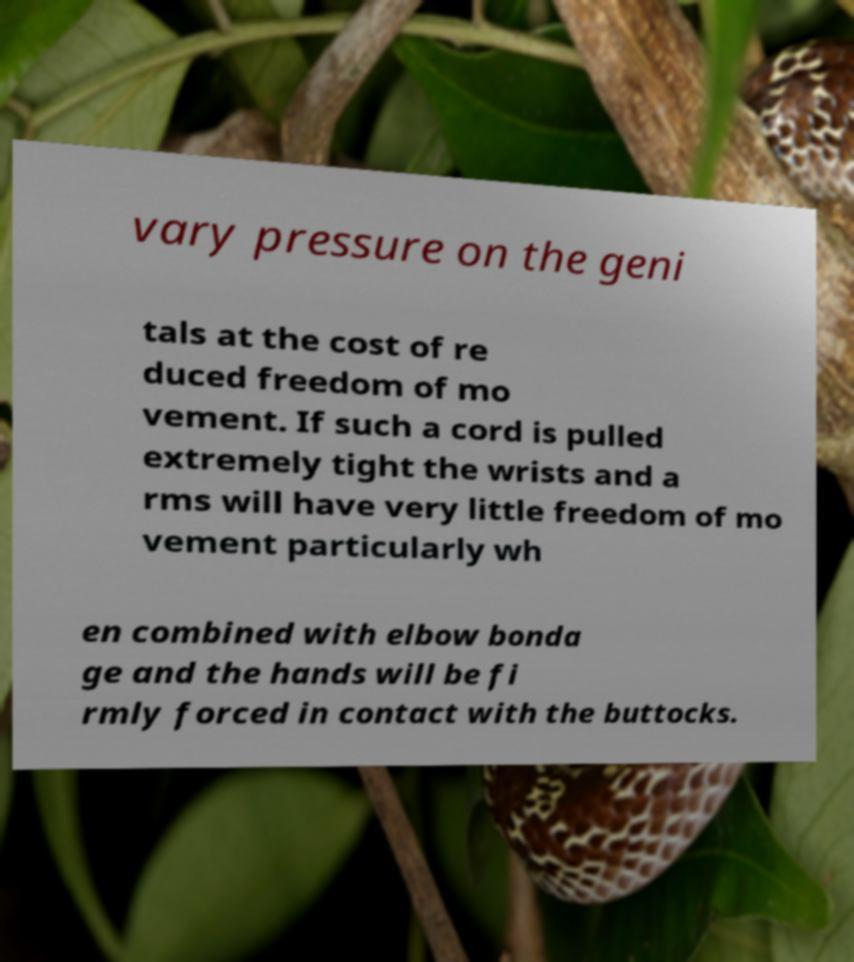Can you read and provide the text displayed in the image?This photo seems to have some interesting text. Can you extract and type it out for me? vary pressure on the geni tals at the cost of re duced freedom of mo vement. If such a cord is pulled extremely tight the wrists and a rms will have very little freedom of mo vement particularly wh en combined with elbow bonda ge and the hands will be fi rmly forced in contact with the buttocks. 